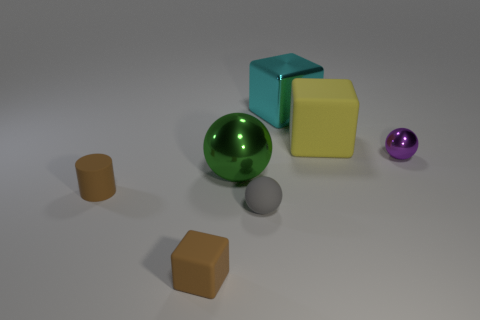What might the purpose of this arrangement of objects be? This arrangement of objects could serve several purposes. It could be a simple display designed to showcase various geometric shapes and textures, or it might be a test scene used by a 3D artist to evaluate rendering techniques. Alternatively, it may represent a still life composition exploring balance and color. 